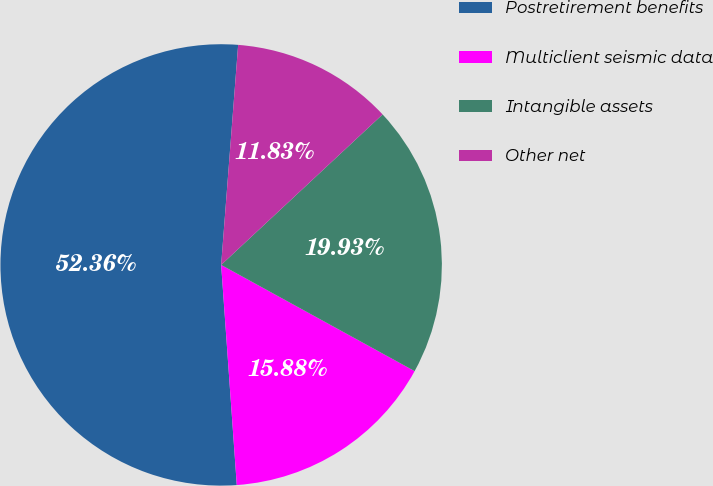Convert chart. <chart><loc_0><loc_0><loc_500><loc_500><pie_chart><fcel>Postretirement benefits<fcel>Multiclient seismic data<fcel>Intangible assets<fcel>Other net<nl><fcel>52.35%<fcel>15.88%<fcel>19.93%<fcel>11.83%<nl></chart> 